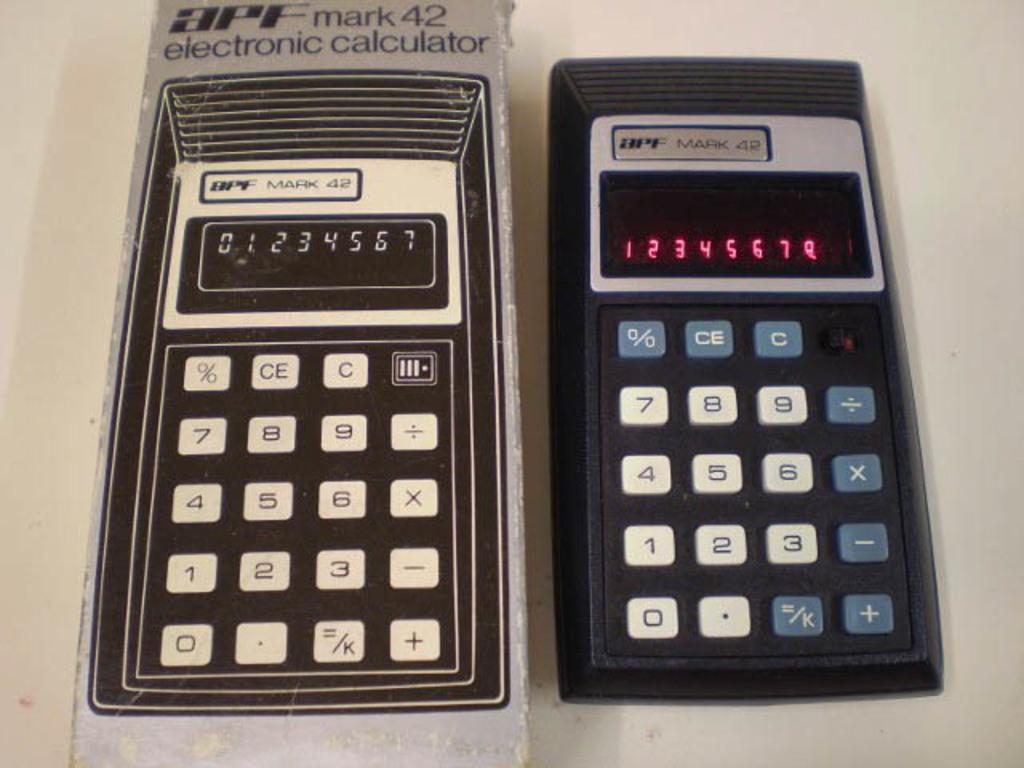What number is shown on the right calculator?
Offer a very short reply. 12345678. What is the name of the calculator written on the box to the left?
Your response must be concise. Apf mark 42. 